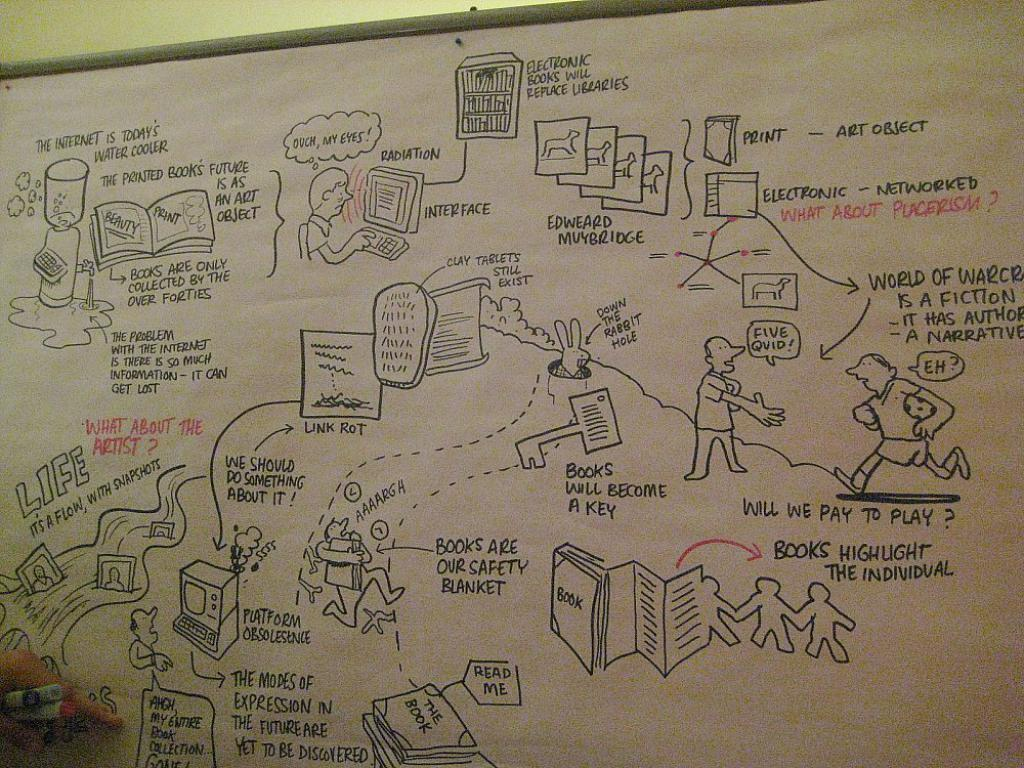<image>
Offer a succinct explanation of the picture presented. the word books is on the front of an item 